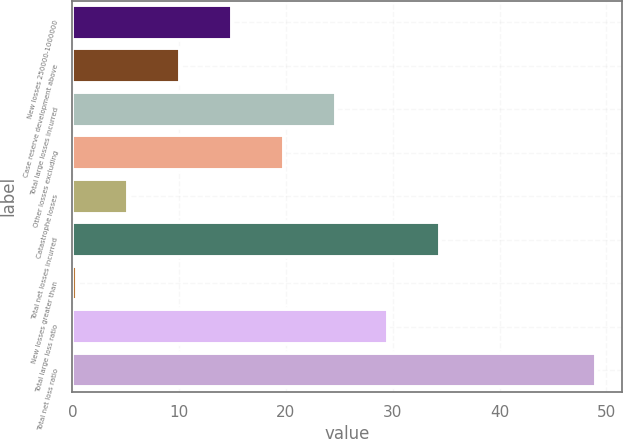<chart> <loc_0><loc_0><loc_500><loc_500><bar_chart><fcel>New losses 250000-1000000<fcel>Case reserve development above<fcel>Total large losses incurred<fcel>Other losses excluding<fcel>Catastrophe losses<fcel>Total net losses incurred<fcel>New losses greater than<fcel>Total large loss ratio<fcel>Total net loss ratio<nl><fcel>14.97<fcel>10.11<fcel>24.69<fcel>19.83<fcel>5.25<fcel>34.41<fcel>0.39<fcel>29.55<fcel>49<nl></chart> 